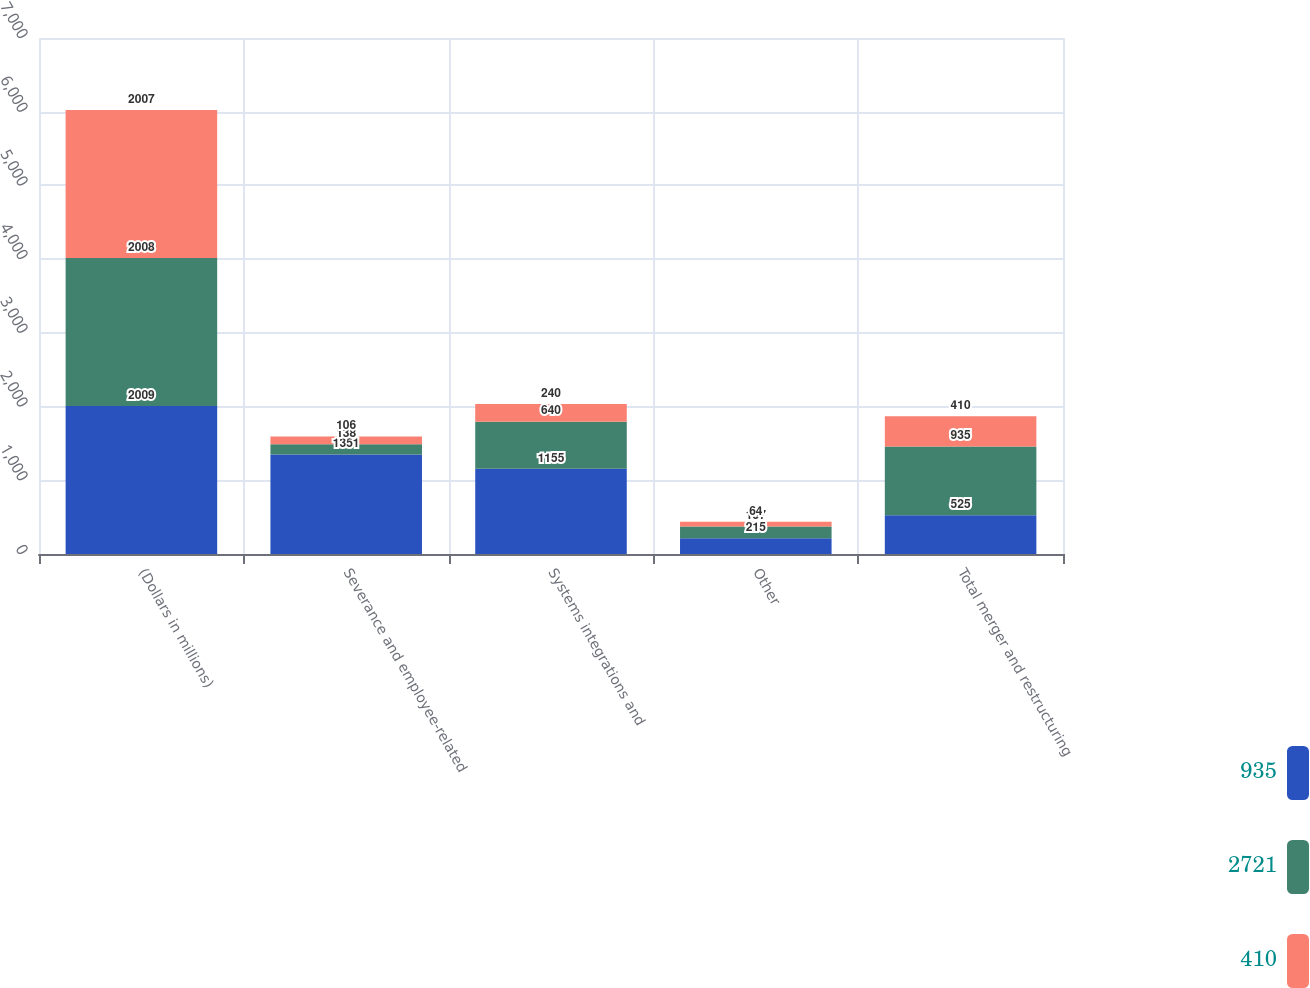Convert chart. <chart><loc_0><loc_0><loc_500><loc_500><stacked_bar_chart><ecel><fcel>(Dollars in millions)<fcel>Severance and employee-related<fcel>Systems integrations and<fcel>Other<fcel>Total merger and restructuring<nl><fcel>935<fcel>2009<fcel>1351<fcel>1155<fcel>215<fcel>525<nl><fcel>2721<fcel>2008<fcel>138<fcel>640<fcel>157<fcel>935<nl><fcel>410<fcel>2007<fcel>106<fcel>240<fcel>64<fcel>410<nl></chart> 